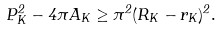<formula> <loc_0><loc_0><loc_500><loc_500>P _ { K } ^ { 2 } - 4 \pi A _ { K } \geq \pi ^ { 2 } ( R _ { K } - r _ { K } ) ^ { 2 } .</formula> 